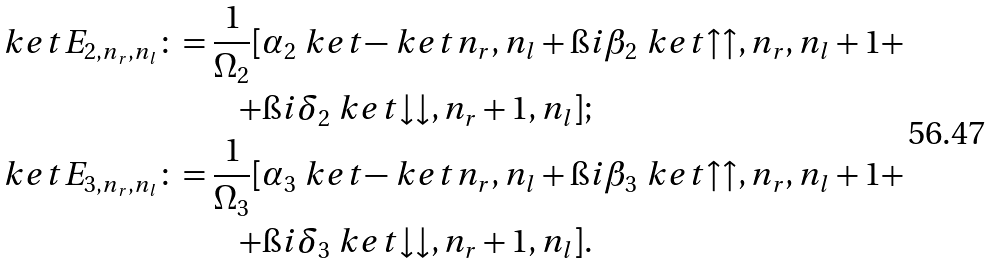Convert formula to latex. <formula><loc_0><loc_0><loc_500><loc_500>\ k e t { E _ { 2 , n _ { r } , n _ { l } } } \colon = \frac { 1 } { \Omega _ { 2 } } [ & \alpha _ { 2 } \ k e t { - } \ k e t { n _ { r } , n _ { l } } + \i i \beta _ { 2 } \ k e t { \uparrow \uparrow , n _ { r } , n _ { l } + 1 } + \\ + & \i i \delta _ { 2 } \ k e t { \downarrow \downarrow , n _ { r } + 1 , n _ { l } } ] ; \\ \ k e t { E _ { 3 , n _ { r } , n _ { l } } } \colon = \frac { 1 } { \Omega _ { 3 } } [ & \alpha _ { 3 } \ k e t { - } \ k e t { n _ { r } , n _ { l } } + \i i \beta _ { 3 } \ k e t { \uparrow \uparrow , n _ { r } , n _ { l } + 1 } + \\ + & \i i \delta _ { 3 } \ k e t { \downarrow \downarrow , n _ { r } + 1 , n _ { l } } ] .</formula> 